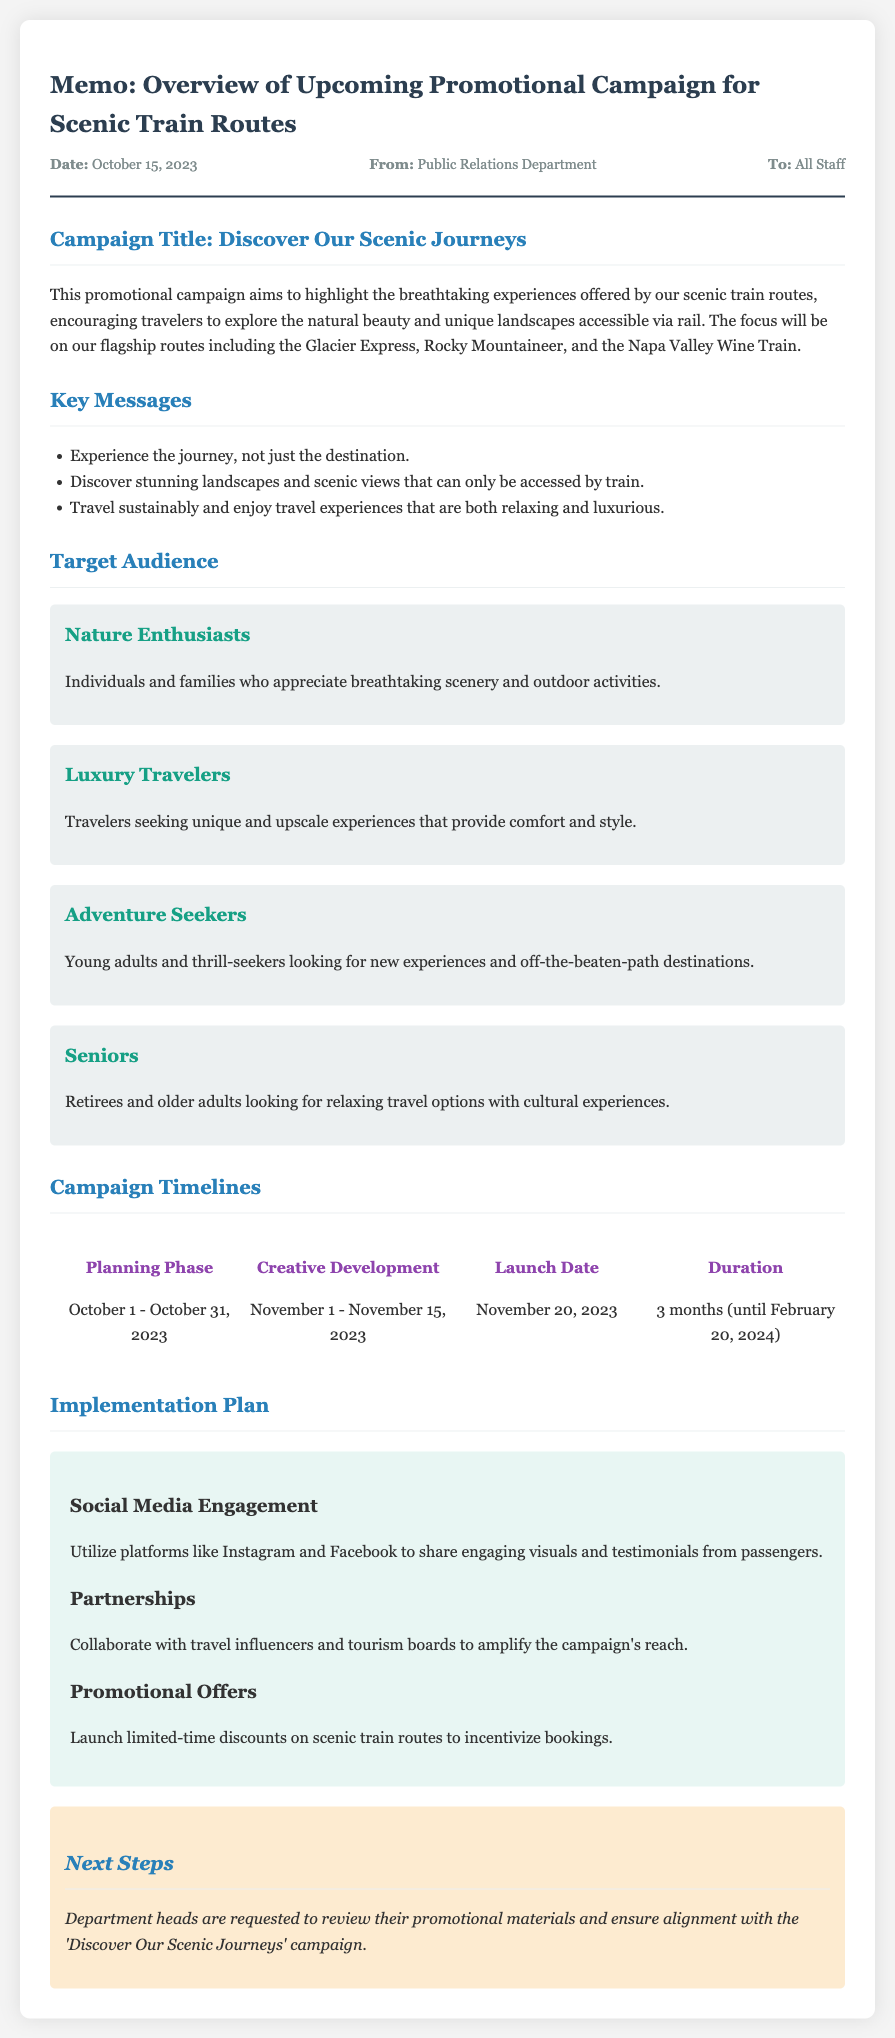What is the name of the campaign? The campaign is titled 'Discover Our Scenic Journeys' as mentioned in the document.
Answer: Discover Our Scenic Journeys When does the planning phase start? The planning phase starts on October 1, 2023.
Answer: October 1, 2023 How long will the campaign last? According to the document, the campaign will last for 3 months.
Answer: 3 months Who is the target audience focused on upscale experiences? The audience segment seeking upscale experiences is identified as 'Luxury Travelers'.
Answer: Luxury Travelers What is the implementation plan for social media? The implementation plan includes utilizing platforms like Instagram and Facebook for engaging visuals and testimonials.
Answer: Social Media Engagement What date is the launch scheduled for? The launch date for the campaign is mentioned as November 20, 2023.
Answer: November 20, 2023 Which scenic train routes are highlighted in the campaign? The highlighted scenic train routes include the Glacier Express, Rocky Mountaineer, and Napa Valley Wine Train.
Answer: Glacier Express, Rocky Mountaineer, Napa Valley Wine Train What action is requested from department heads? The document requests department heads to review their promotional materials for alignment with the campaign.
Answer: Review promotional materials What type of traveler is characterized by seeking new experiences? The segment looking for new experiences is referred to as 'Adventure Seekers'.
Answer: Adventure Seekers 